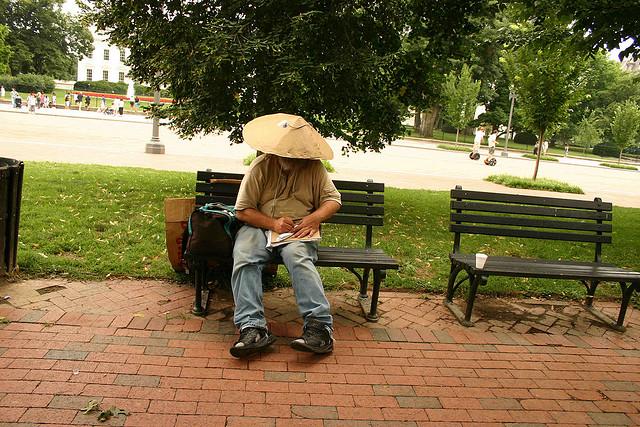Where is the man seated?
Quick response, please. Bench. Does the man have something on his head?
Keep it brief. Yes. Can you see other people in the picture?
Concise answer only. Yes. 